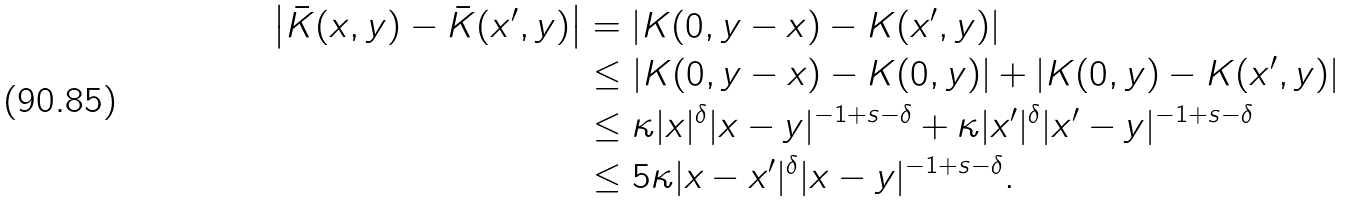Convert formula to latex. <formula><loc_0><loc_0><loc_500><loc_500>\left | \bar { K } ( x , y ) - \bar { K } ( x ^ { \prime } , y ) \right | & = \left | K ( 0 , y - x ) - K ( x ^ { \prime } , y ) \right | \\ & \leq \left | K ( 0 , y - x ) - K ( 0 , y ) \right | + \left | K ( 0 , y ) - K ( x ^ { \prime } , y ) \right | \\ & \leq \kappa | x | ^ { \delta } | x - y | ^ { - 1 + s - \delta } + \kappa | x ^ { \prime } | ^ { \delta } | x ^ { \prime } - y | ^ { - 1 + s - \delta } \\ & \leq 5 \kappa | x - x ^ { \prime } | ^ { \delta } | x - y | ^ { - 1 + s - \delta } .</formula> 